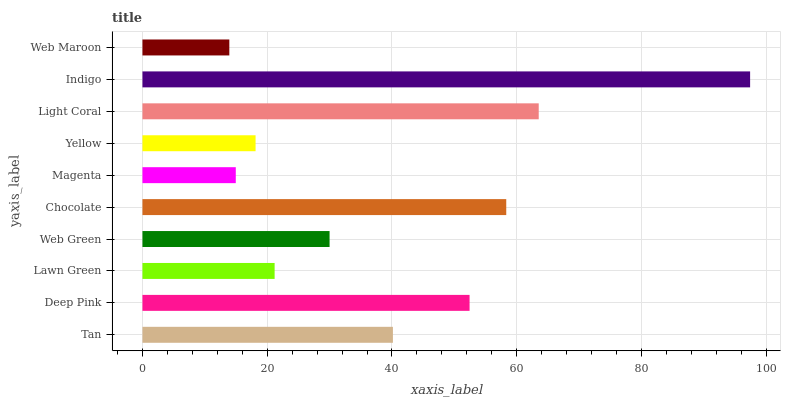Is Web Maroon the minimum?
Answer yes or no. Yes. Is Indigo the maximum?
Answer yes or no. Yes. Is Deep Pink the minimum?
Answer yes or no. No. Is Deep Pink the maximum?
Answer yes or no. No. Is Deep Pink greater than Tan?
Answer yes or no. Yes. Is Tan less than Deep Pink?
Answer yes or no. Yes. Is Tan greater than Deep Pink?
Answer yes or no. No. Is Deep Pink less than Tan?
Answer yes or no. No. Is Tan the high median?
Answer yes or no. Yes. Is Web Green the low median?
Answer yes or no. Yes. Is Deep Pink the high median?
Answer yes or no. No. Is Deep Pink the low median?
Answer yes or no. No. 